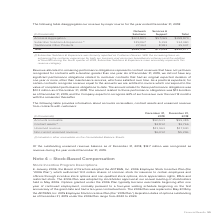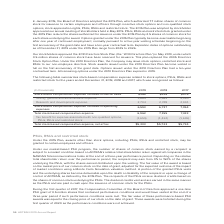According to Adtran's financial document, Which year did all the remaining options under the 2010 Directors Plan expire? According to the financial document, 2019. The relevant text states: "uration greater than one year. As of December 31, 2019, we did not have any significant performance obligations related to customer contracts that had an..." Also, What did the 2015 Plan authorize? 7.7 million shares of common stock for issuance to certain employees and officers through incentive stock options and non-qualified stock options, stock appreciation rights, PSUs, RSUs and restricted stock.. The document states: "Directors adopted the 2015 Plan, which authorized 7.7 million shares of common stock for issuance to certain employees and officers through incentive ..." Also, What was the research and development expense in 2019? According to the financial document, 2,704 (in thousands). The relevant text states: "Research and development expense 2,704 2,748 2,991..." Also, can you calculate: What was the change in research and development expense between 2018 and 2019? Based on the calculation: 2,704-2,748, the result is -44 (in thousands). This is based on the information: "Research and development expense 2,704 2,748 2,991 Research and development expense 2,704 2,748 2,991..." The key data points involved are: 2,704, 2,748. Also, can you calculate: What was the change in total stock-based compensation expense between 2018 and 2019? Based on the calculation: 6,962-7,155, the result is -193 (in thousands). This is based on the information: "Total stock-based compensation expense 6,962 7,155 7,433 Total stock-based compensation expense 6,962 7,155 7,433..." The key data points involved are: 6,962, 7,155. Also, can you calculate: What was the percentage change in total stock-based compensation expense, net of tax between 2017 and 2018? To answer this question, I need to perform calculations using the financial data. The calculation is: ($5,723-$5,734)/$5,734, which equals -0.19 (percentage). This is based on the information: "d compensation expense, net of tax $5,303 $5,723 $5,734 ck-based compensation expense, net of tax $5,303 $5,723 $5,734..." The key data points involved are: 5,723, 5,734. 